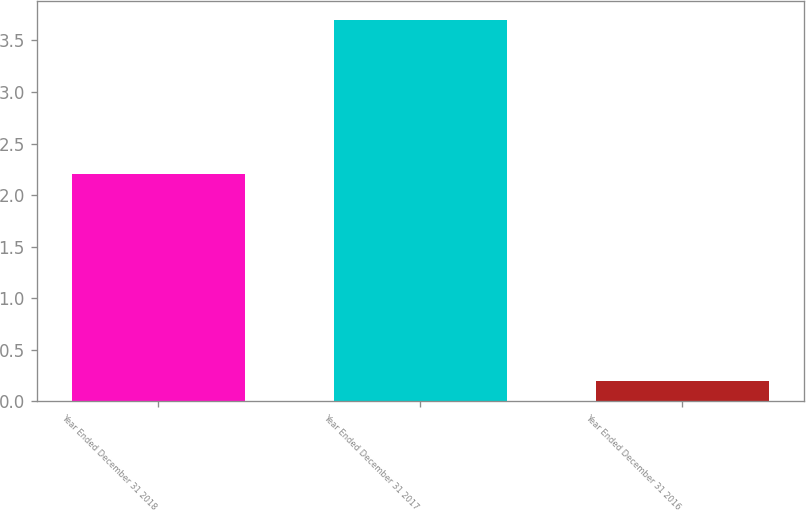<chart> <loc_0><loc_0><loc_500><loc_500><bar_chart><fcel>Year Ended December 31 2018<fcel>Year Ended December 31 2017<fcel>Year Ended December 31 2016<nl><fcel>2.2<fcel>3.7<fcel>0.2<nl></chart> 